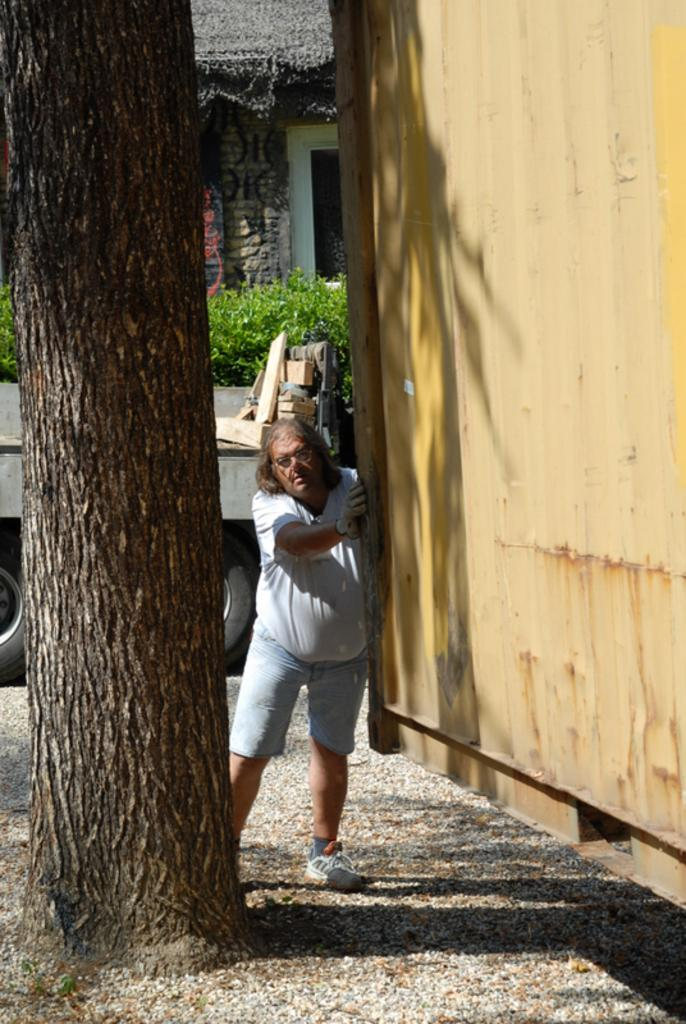What is the lady standing beside in the image? The lady is standing beside a metal wall in the image. What can be seen on the other side of the metal wall? There is a tree on the other side of the metal wall. What is visible in the background of the image? There is a vehicle, trees, and a house in the background of the image. How many snails are crawling on the lady's shoes in the image? There are no snails visible in the image, so it is not possible to determine how many might be on the lady's shoes. 